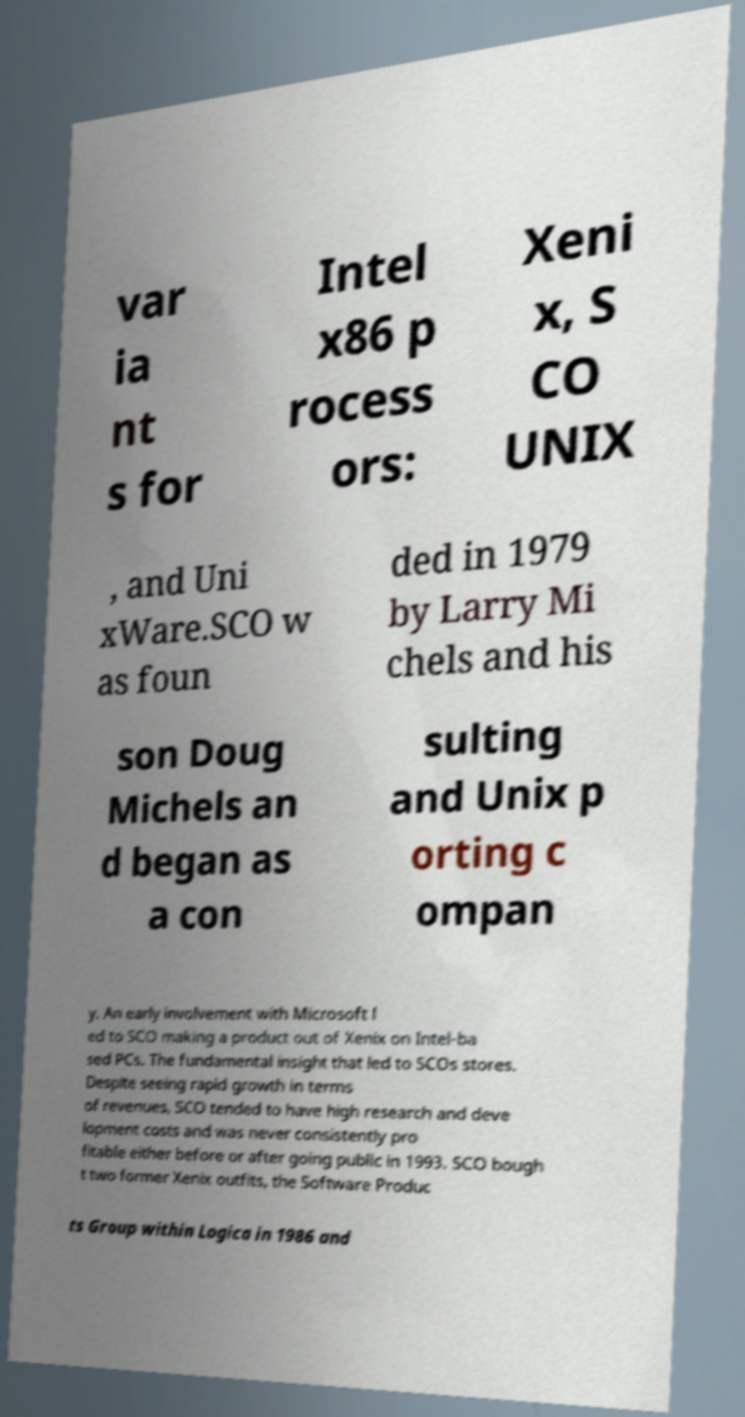Could you assist in decoding the text presented in this image and type it out clearly? var ia nt s for Intel x86 p rocess ors: Xeni x, S CO UNIX , and Uni xWare.SCO w as foun ded in 1979 by Larry Mi chels and his son Doug Michels an d began as a con sulting and Unix p orting c ompan y. An early involvement with Microsoft l ed to SCO making a product out of Xenix on Intel-ba sed PCs. The fundamental insight that led to SCOs stores. Despite seeing rapid growth in terms of revenues, SCO tended to have high research and deve lopment costs and was never consistently pro fitable either before or after going public in 1993. SCO bough t two former Xenix outfits, the Software Produc ts Group within Logica in 1986 and 